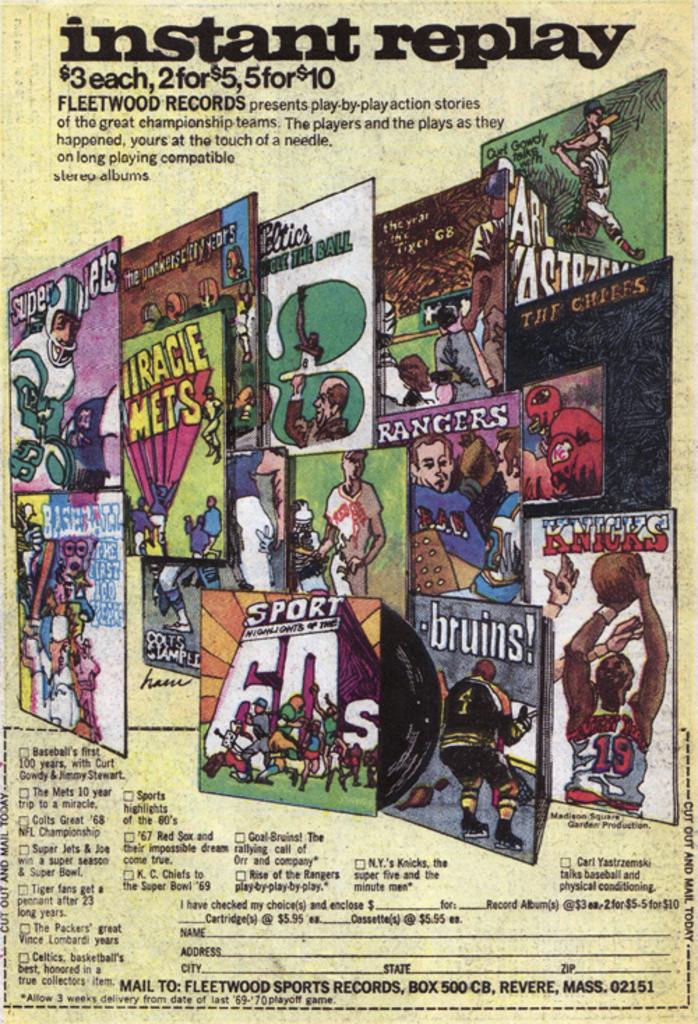What does the text say at the top of the poster?
Provide a succinct answer. Instant replay. 